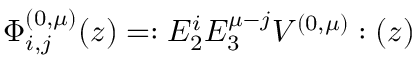Convert formula to latex. <formula><loc_0><loc_0><loc_500><loc_500>\Phi _ { i , j } ^ { ( 0 , \mu ) } ( z ) = \colon E _ { 2 } ^ { i } E _ { 3 } ^ { \mu - j } V ^ { ( 0 , \mu ) } \colon ( z )</formula> 